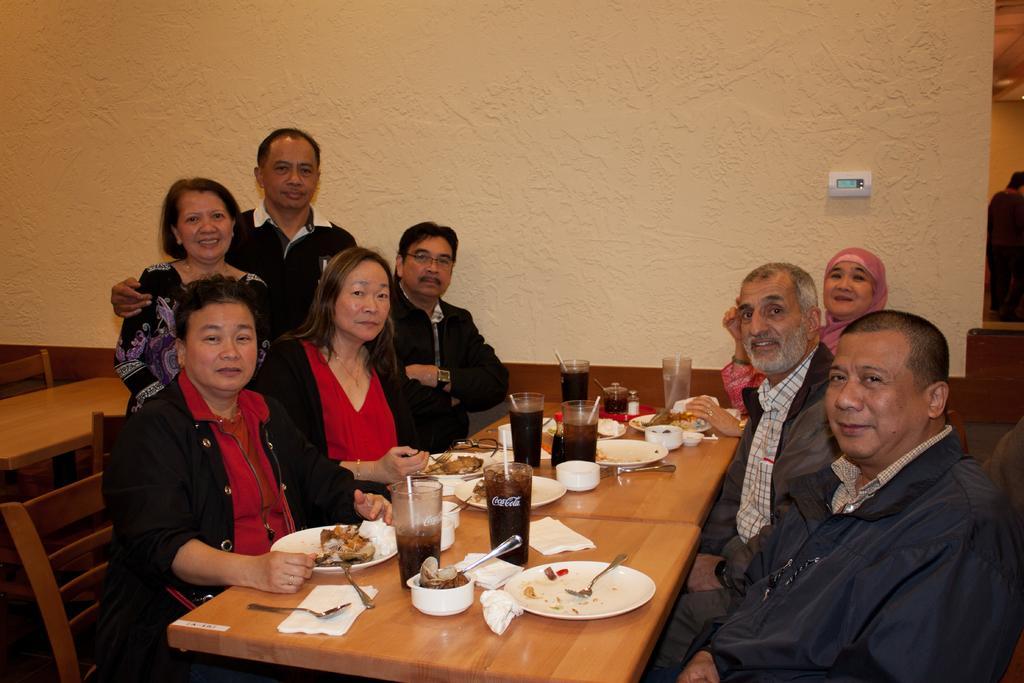Describe this image in one or two sentences. In this picture there are several people sitting on a brown table with food items on top of it. 